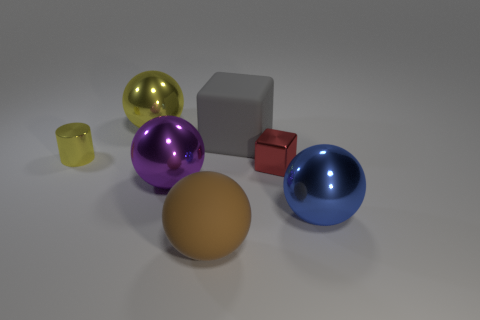There is a cube that is behind the object that is on the left side of the big metal sphere behind the small red block; what is it made of?
Offer a terse response. Rubber. Are there an equal number of big gray objects left of the big yellow metallic thing and large purple metal objects?
Offer a very short reply. No. Are the cube in front of the yellow metallic cylinder and the yellow object that is to the right of the tiny yellow cylinder made of the same material?
Ensure brevity in your answer.  Yes. What number of objects are either small gray spheres or yellow metallic things that are on the left side of the big yellow ball?
Provide a short and direct response. 1. Are there any big purple things that have the same shape as the large yellow object?
Offer a very short reply. Yes. There is a purple metal object that is in front of the small metal object that is to the right of the large ball that is in front of the blue metal sphere; how big is it?
Keep it short and to the point. Large. Is the number of small yellow metallic cylinders that are on the left side of the tiny shiny cylinder the same as the number of big matte spheres that are in front of the blue ball?
Keep it short and to the point. No. The cube that is made of the same material as the small yellow object is what size?
Offer a very short reply. Small. What color is the shiny cylinder?
Make the answer very short. Yellow. What number of large matte cubes are the same color as the metal cylinder?
Your answer should be very brief. 0. 